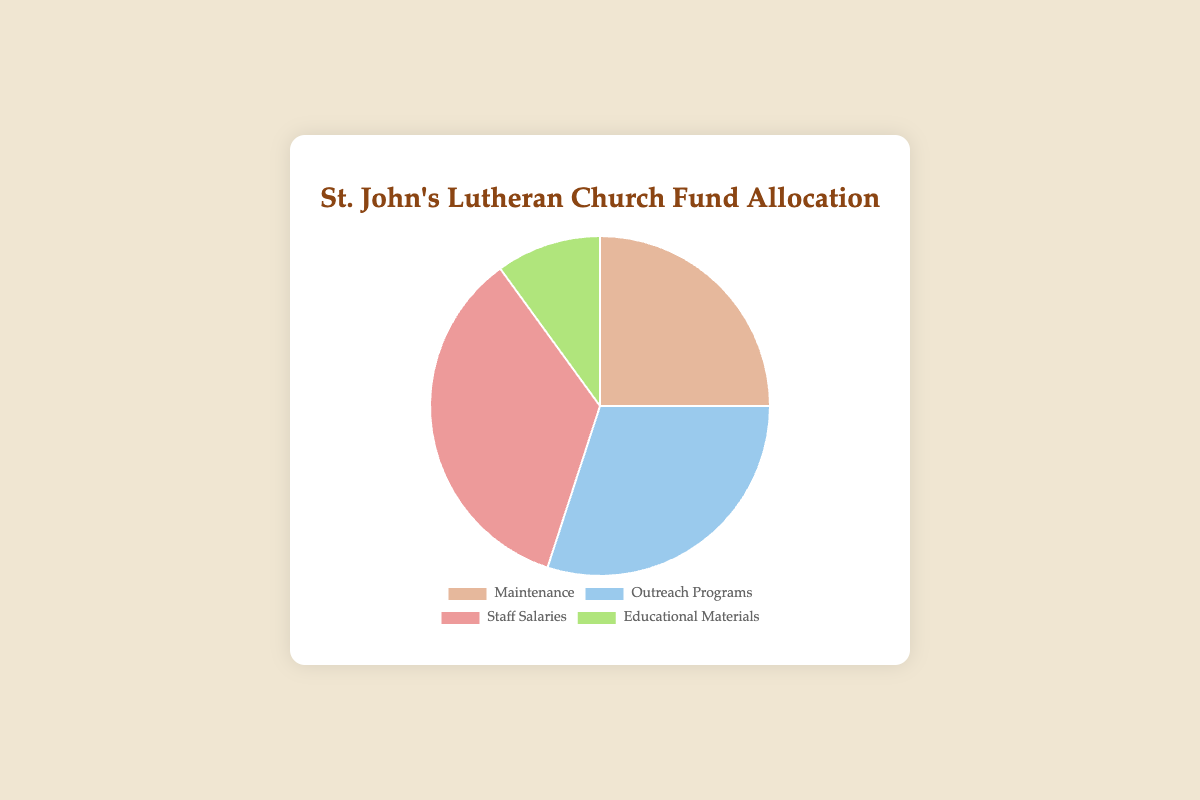Which category has the highest percentage in the fund allocation? By looking at the pie chart, we observe that "Staff Salaries" has the largest segment compared to the others.
Answer: Staff Salaries What is the combined percentage for Maintenance and Educational Materials? Maintenance has 25% and Educational Materials have 10%. Adding these together gives 35%.
Answer: 35% Which category has the lowest percentage in the fund allocation? The pie chart shows four categories, and the smallest slice corresponds to "Educational Materials" which has a 10% allocation.
Answer: Educational Materials How much more percentage is allocated to Outreach Programs compared to Educational Materials? Outreach Programs is allocated 30%, and Educational Materials is allocated 10%. Subtracting 10% from 30% gives a difference of 20%.
Answer: 20% Is the percentage allocated to Staff Salaries more than the combined allocation of Maintenance and Educational Materials? Staff Salaries is allocated 35%, while Maintenance and Educational Materials together make up 25% + 10% = 35%. They are equal, so Staff Salaries is not more than the combined allocation.
Answer: No If the total budget is $100,000, how much money is allocated to Outreach Programs? First, find the percentage of the total budget for Outreach Programs, which is 30%. Then calculate 30% of $100,000, which is $100,000 * 0.30 = $30,000.
Answer: $30,000 What is the difference in percentage between Maintenance and Staff Salaries? Staff Salaries has a 35% allocation, and Maintenance has a 25% allocation. The difference is 35% - 25% = 10%.
Answer: 10% Which slice of the pie chart represents 10% of the fund allocation? The pie chart shows that "Educational Materials" represents 10% of the total fund allocation.
Answer: Educational Materials What percentage of the fund allocation is devoted to categories excluding Outreach Programs? Excluding Outreach Programs means summing up the percentages of Maintenance (25%), Staff Salaries (35%), and Educational Materials (10%). So, 25% + 35% + 10% = 70%.
Answer: 70% If the fund for Outreach Programs increases by 5%, what will be its new percentage? The current percentage for Outreach Programs is 30%. Adding 5% results in 30% + 5% = 35%.
Answer: 35% 